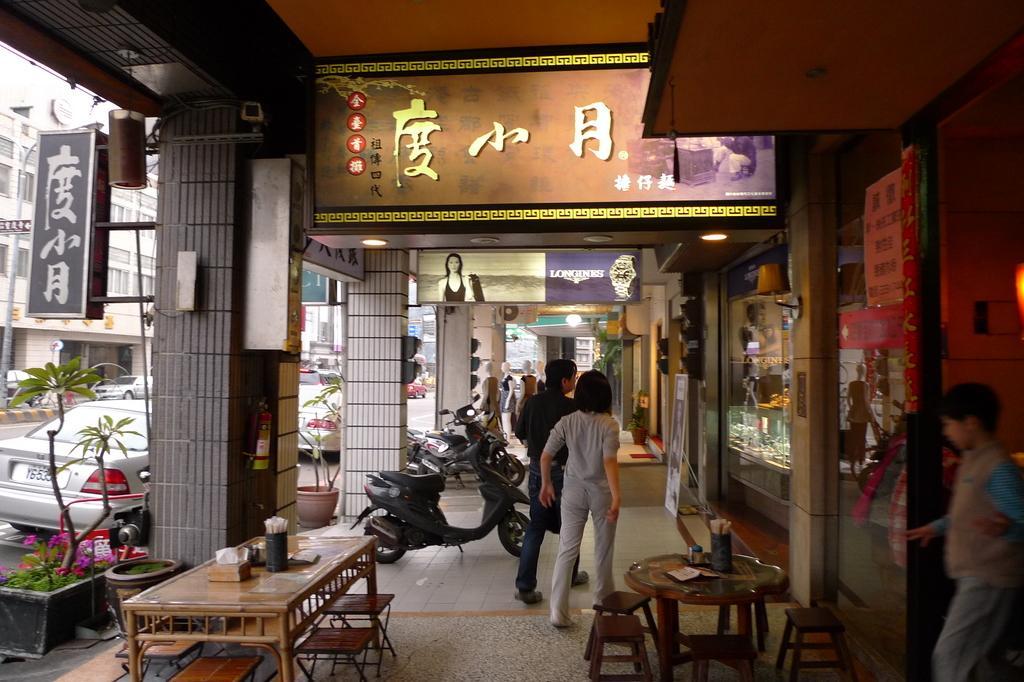Can you describe this image briefly? In this image I can see few persons standing on the ground, few tables with few chairs around them, few boards, a flower pot with a plant and few flowers which are pink in color. I can see few motorbikes on the ground, few vehicles on the road and few buildings. 